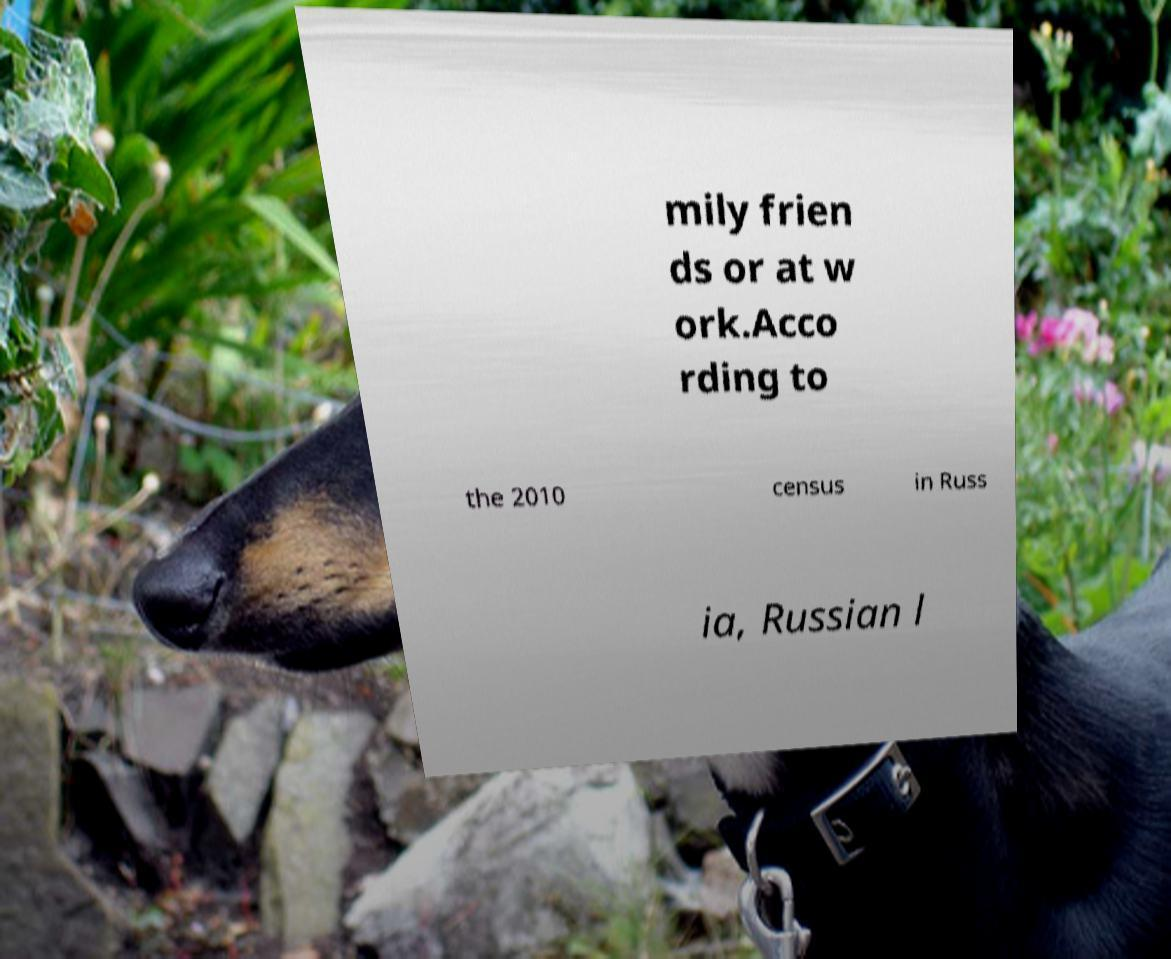What messages or text are displayed in this image? I need them in a readable, typed format. mily frien ds or at w ork.Acco rding to the 2010 census in Russ ia, Russian l 